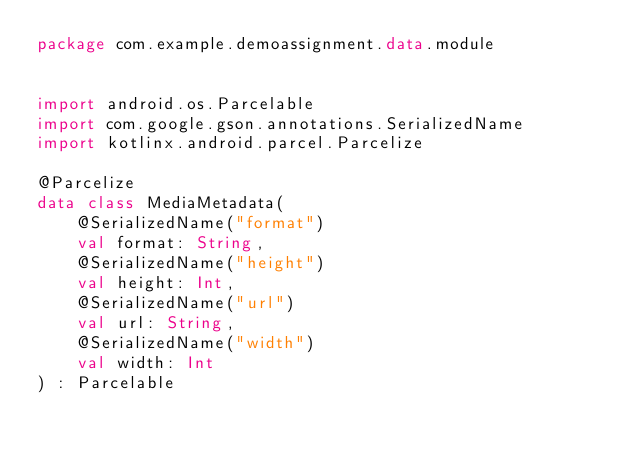Convert code to text. <code><loc_0><loc_0><loc_500><loc_500><_Kotlin_>package com.example.demoassignment.data.module


import android.os.Parcelable
import com.google.gson.annotations.SerializedName
import kotlinx.android.parcel.Parcelize

@Parcelize
data class MediaMetadata(
    @SerializedName("format")
    val format: String,
    @SerializedName("height")
    val height: Int,
    @SerializedName("url")
    val url: String,
    @SerializedName("width")
    val width: Int
) : Parcelable</code> 